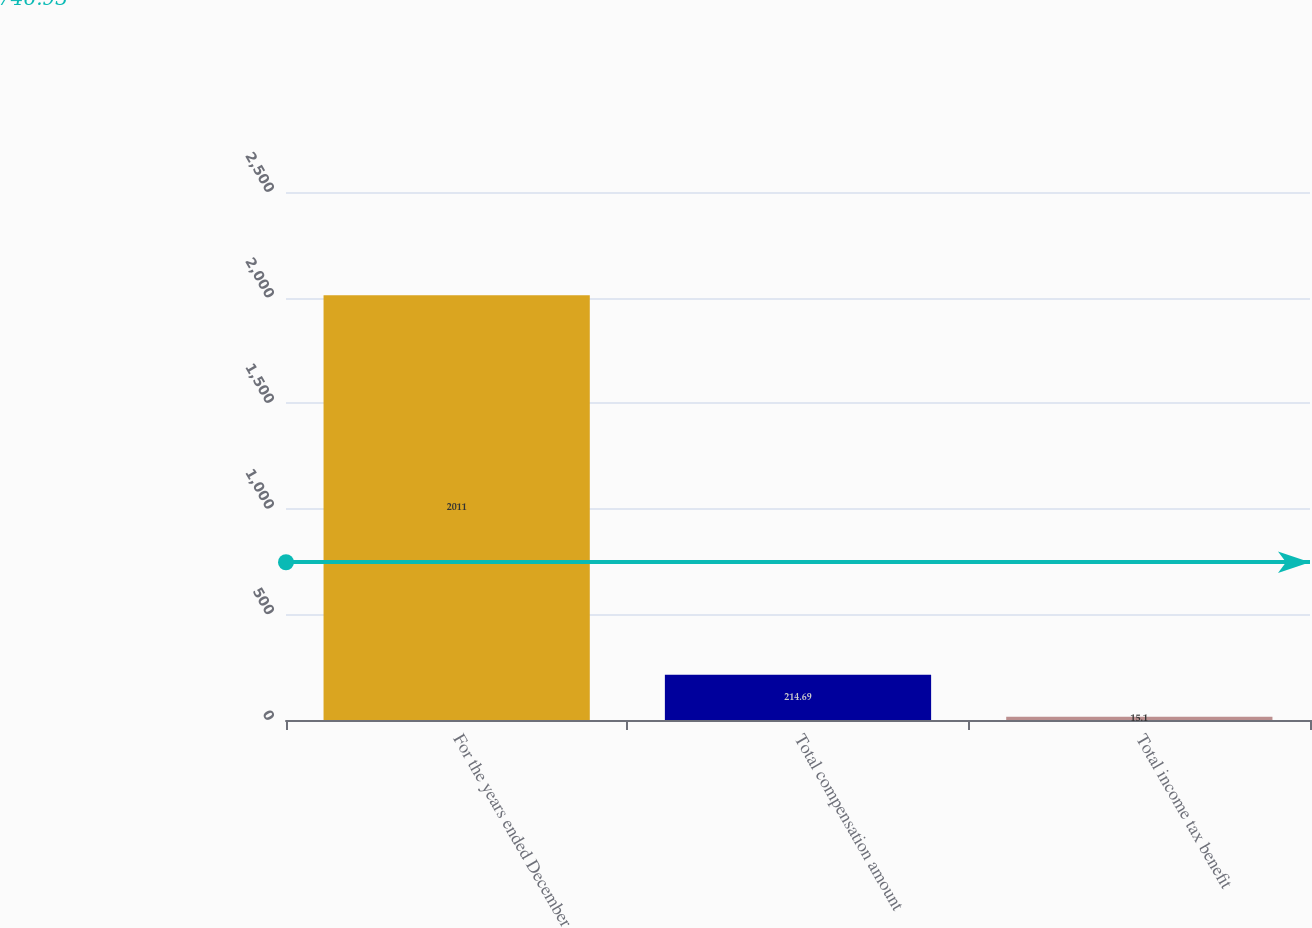Convert chart. <chart><loc_0><loc_0><loc_500><loc_500><bar_chart><fcel>For the years ended December<fcel>Total compensation amount<fcel>Total income tax benefit<nl><fcel>2011<fcel>214.69<fcel>15.1<nl></chart> 